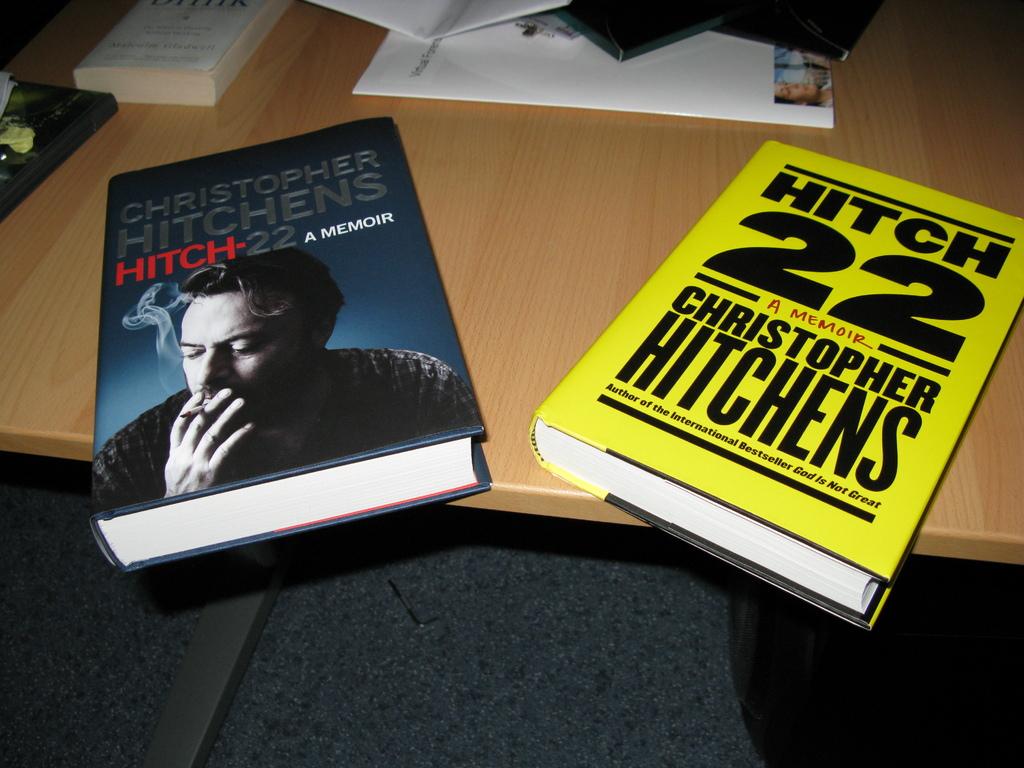Who wrote the book(s)?
Your answer should be very brief. Christopher hitchens. What are the books' names?
Give a very brief answer. Hitch 22. 